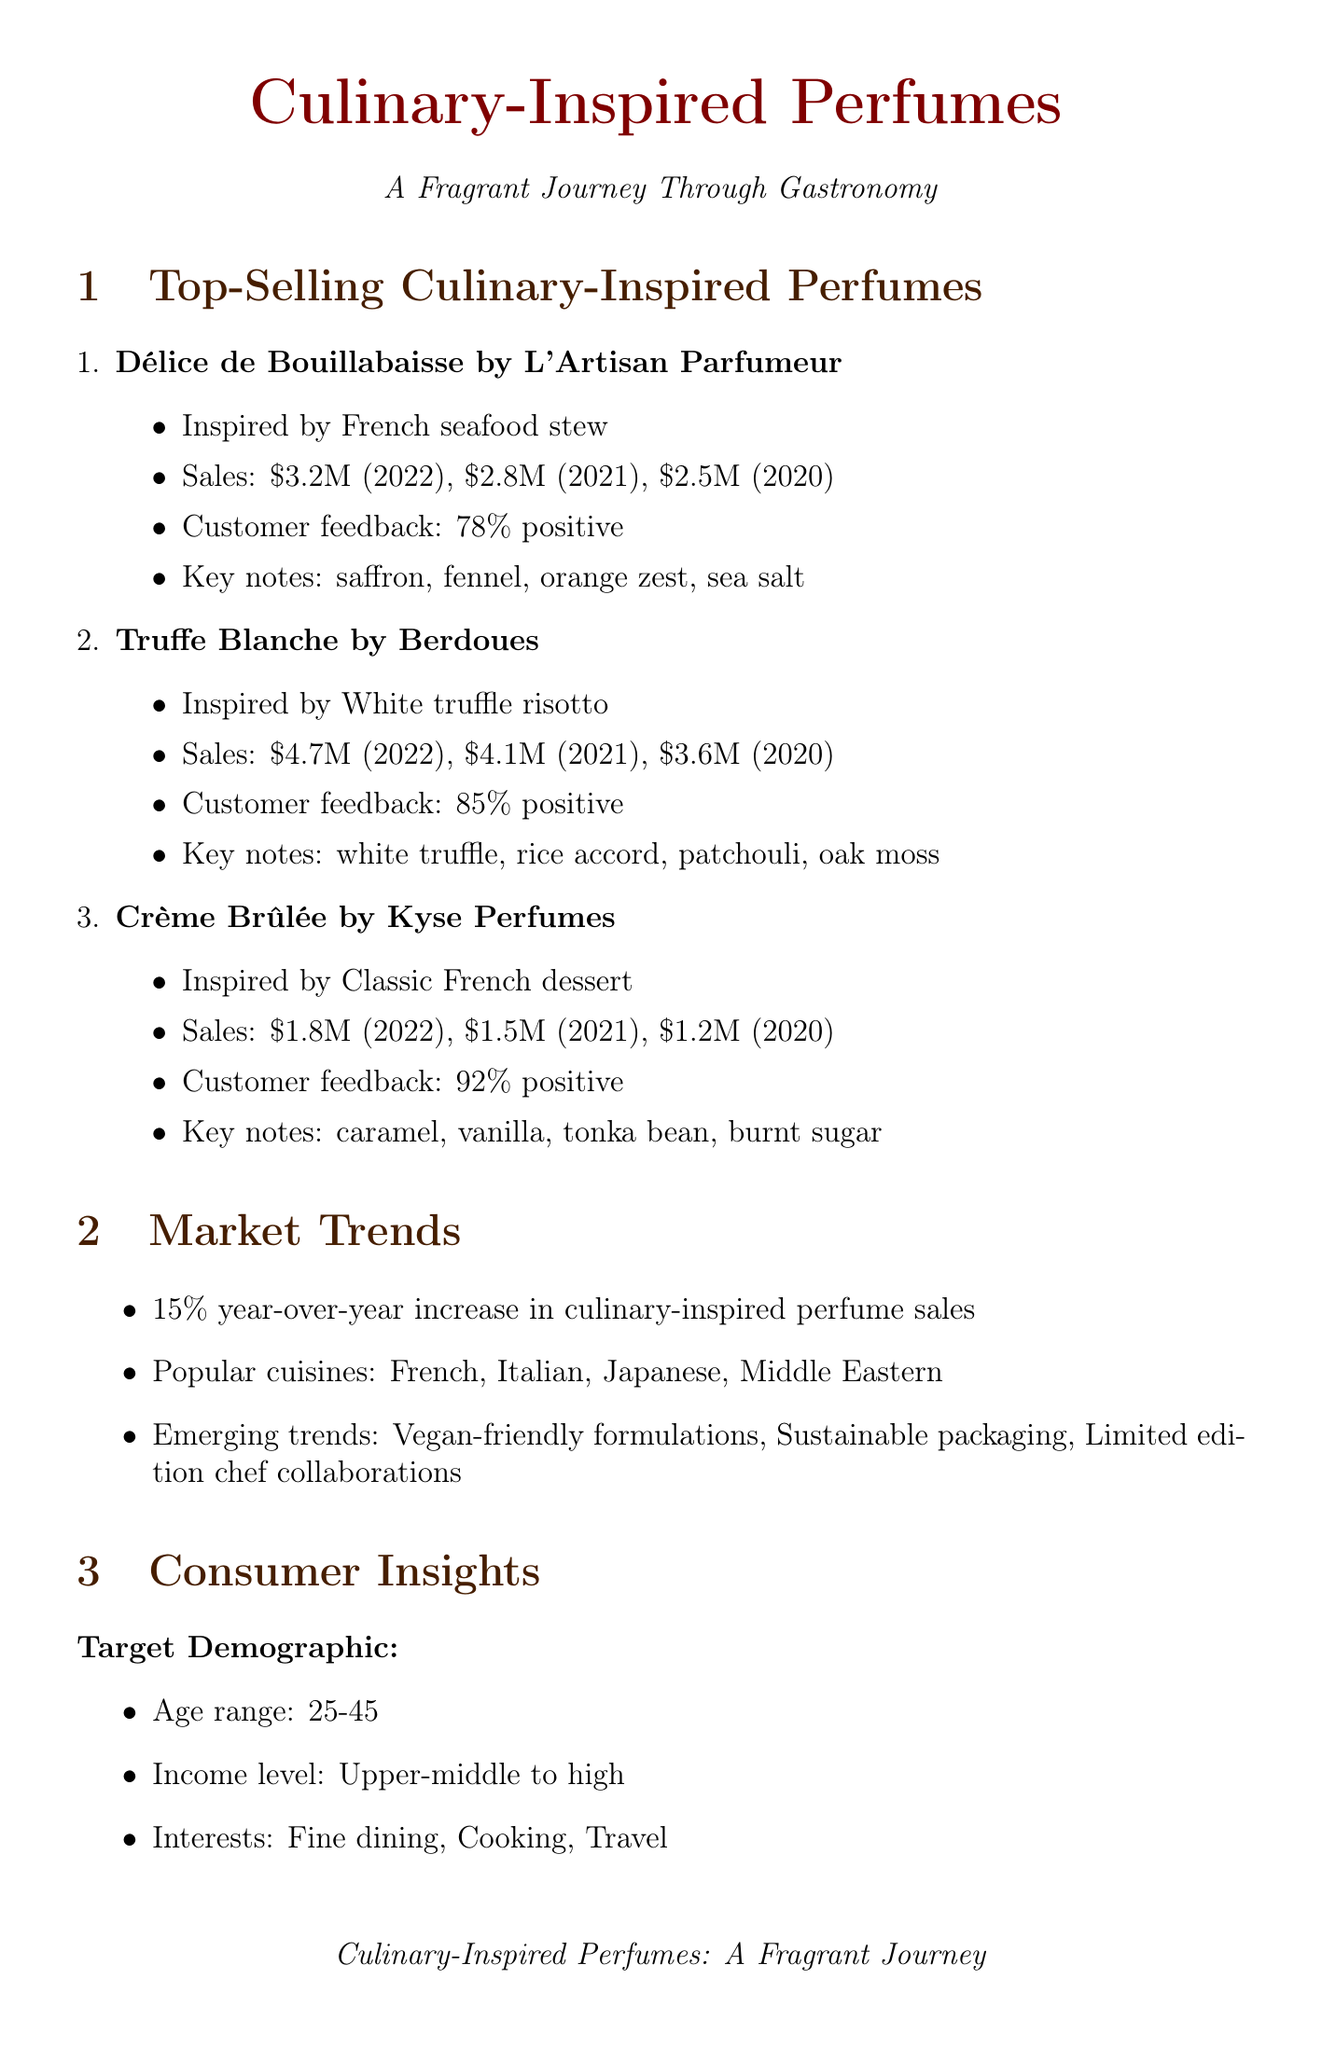what is the sales figure for Truffe Blanche in 2022? The sales figure for Truffe Blanche in 2022 is found under the sales_figures section of the document, which states it as $4.7 million.
Answer: $4.7 million what is the customer feedback percentage for Crème Brûlée? The customer feedback percentage for Crème Brûlée is provided in the customer_feedback section of the document, which shows 92% positive feedback.
Answer: 92% which key note is included in Délice de Bouillabaisse? The key notes for Délice de Bouillabaisse are explicitly listed in the document, and one of them is saffron.
Answer: saffron what is the overall growth rate of culinary-inspired perfume sales? The overall growth rate is stated in the market_trends section of the document, which mentions a 15% year-over-year increase.
Answer: 15% who is the Master Perfumer quoted in the document? The document contains a quote from Francis Kurkdjian, who is identified as the Master Perfumer.
Answer: Francis Kurkdjian what emerging trend is listed in the market trends? The market trends section mentions several emerging trends, one of which is vegan-friendly formulations.
Answer: Vegan-friendly formulations what is the estimated market size by 2025? The estimated market size by 2025 can be found in the future projections section, which states it as $1.2 billion.
Answer: $1.2 billion what are two popular cuisines mentioned in the document? The popular cuisines are listed in the market_trends section, and two of them are French and Italian.
Answer: French, Italian 